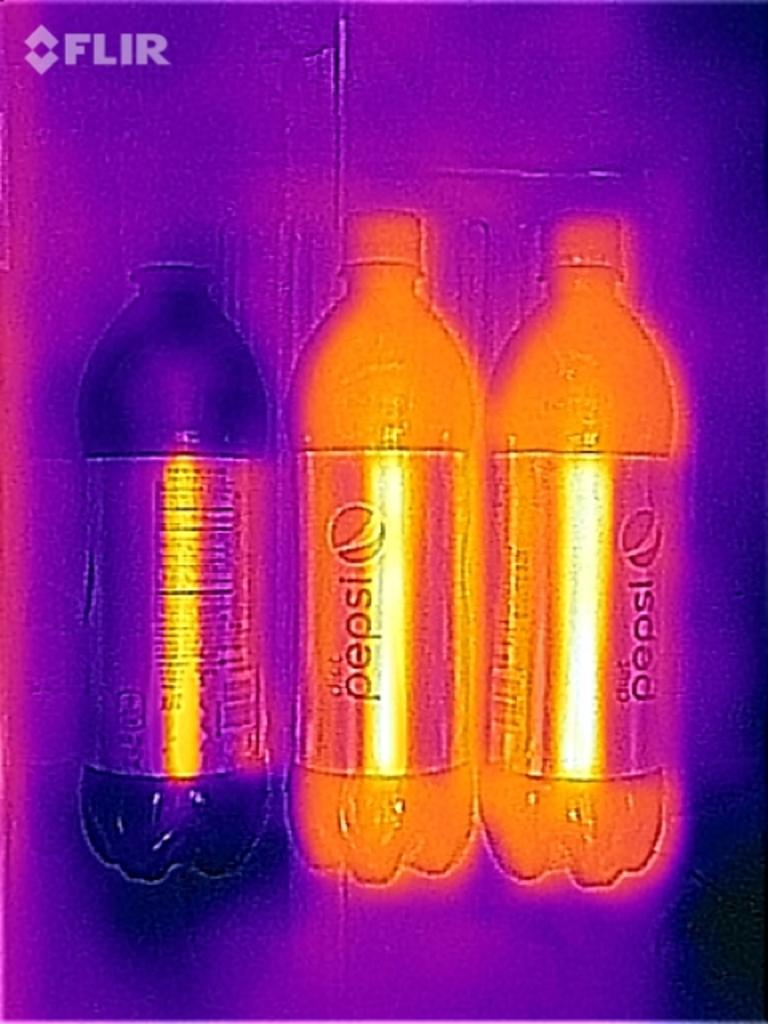<image>
Write a terse but informative summary of the picture. Three pepsi bottles, one is black, the others are orange. 